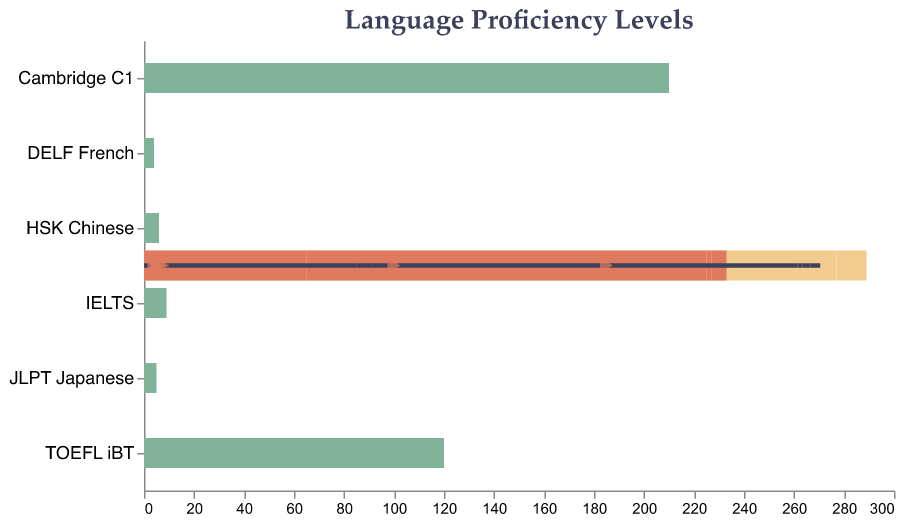What is the title of the chart? The title is usually the first thing you see and is located at the top of the chart. In this case, it states "Language Proficiency Levels".
Answer: Language Proficiency Levels What is the current proficiency level for TOEFL iBT? The current proficiency level can be identified by looking at the dark bar mark. For TOEFL iBT, it aligns with '85'.
Answer: 85 What is the target level for JLPT Japanese? Look at the target level, which is represented by a triangle symbol. For JLPT Japanese, it points to '5'.
Answer: 5 Which language proficiency test has the highest expert level? Reviewing the bars representing the "Expert" levels, we see that Cambridge C1 has the highest expert level, noted at '210'.
Answer: Cambridge C1 How many sections are there for each language proficiency band? Each language section of the bullet chart features four colored bars (for Beginner, Intermediate, Advanced, Expert) and a dark divider for current level along with a triangular marker for the target level.
Answer: 4 What is the difference between the target level and current level for IELTS? To find the difference, subtract the current level from the target level for IELTS: 7.5 - 6.5 = 1.
Answer: 1 Which language test has the smallest gap between current and target levels? Examine each language proficiency test's current and target levels. DELF French has the smallest gap (Current: B1 (2), Target: C1 (4)), which is '2'.
Answer: DELF French Which language proficiency tests have met or exceeded the Intermediate level? Reviewing the dark-colored bars, TOEFL iBT, Cambridge C1, DELF French, JLPT Japanese, and HSK Chinese all meet or exceed their Intermediate levels. IELTS is just below.
Answer: TOEFL iBT, Cambridge C1, DELF French, JLPT Japanese, HSK Chinese What can you say about the progress needed for HSK Chinese to reach its target level compared to its current level? The target level for HSK Chinese is at 6, starting from a current level of 4. This represents a progress requirement from level 4 to 6, which is an increase of '2 levels'.
Answer: 2 levels 